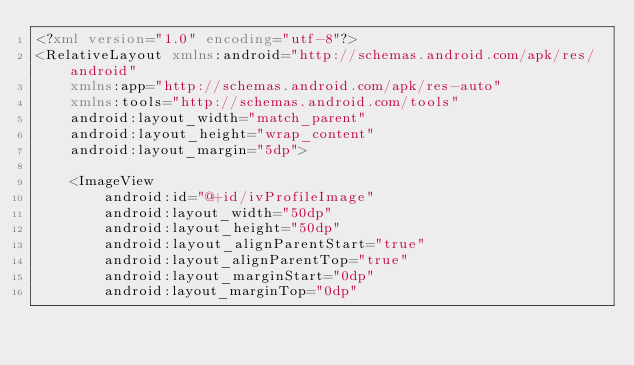<code> <loc_0><loc_0><loc_500><loc_500><_XML_><?xml version="1.0" encoding="utf-8"?>
<RelativeLayout xmlns:android="http://schemas.android.com/apk/res/android"
    xmlns:app="http://schemas.android.com/apk/res-auto"
    xmlns:tools="http://schemas.android.com/tools"
    android:layout_width="match_parent"
    android:layout_height="wrap_content"
    android:layout_margin="5dp">

    <ImageView
        android:id="@+id/ivProfileImage"
        android:layout_width="50dp"
        android:layout_height="50dp"
        android:layout_alignParentStart="true"
        android:layout_alignParentTop="true"
        android:layout_marginStart="0dp"
        android:layout_marginTop="0dp"</code> 